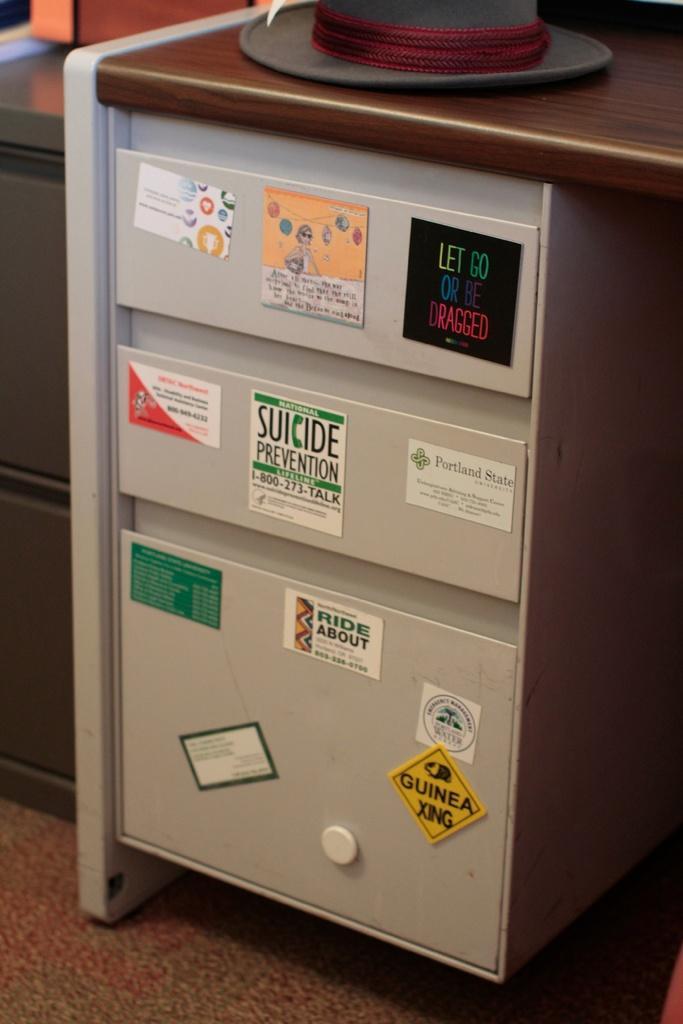Describe this image in one or two sentences. In this image I can see a rack which is in white color and few stickers are attached to the rack. We can see what on the table. 